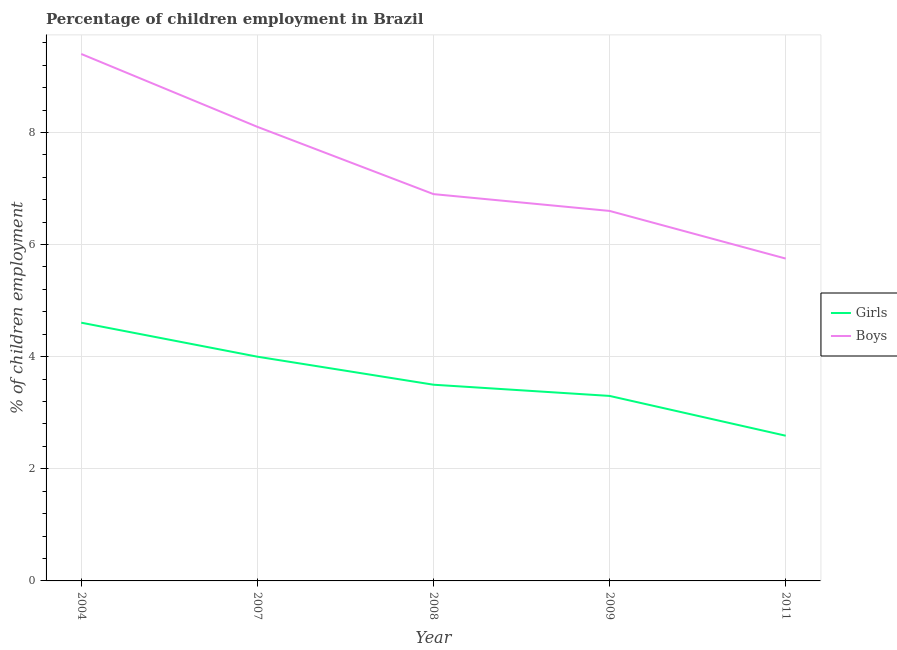How many different coloured lines are there?
Keep it short and to the point. 2. Does the line corresponding to percentage of employed girls intersect with the line corresponding to percentage of employed boys?
Offer a very short reply. No. Across all years, what is the maximum percentage of employed boys?
Your answer should be compact. 9.4. Across all years, what is the minimum percentage of employed girls?
Your answer should be very brief. 2.59. In which year was the percentage of employed boys maximum?
Your answer should be very brief. 2004. In which year was the percentage of employed boys minimum?
Your answer should be very brief. 2011. What is the total percentage of employed girls in the graph?
Give a very brief answer. 18. What is the difference between the percentage of employed boys in 2004 and that in 2008?
Give a very brief answer. 2.5. What is the difference between the percentage of employed girls in 2004 and the percentage of employed boys in 2007?
Provide a short and direct response. -3.49. What is the average percentage of employed girls per year?
Offer a terse response. 3.6. In the year 2007, what is the difference between the percentage of employed boys and percentage of employed girls?
Your response must be concise. 4.1. What is the ratio of the percentage of employed girls in 2008 to that in 2009?
Offer a very short reply. 1.06. What is the difference between the highest and the second highest percentage of employed girls?
Give a very brief answer. 0.61. What is the difference between the highest and the lowest percentage of employed girls?
Provide a succinct answer. 2.02. Is the sum of the percentage of employed boys in 2007 and 2009 greater than the maximum percentage of employed girls across all years?
Your answer should be compact. Yes. What is the difference between two consecutive major ticks on the Y-axis?
Provide a short and direct response. 2. Are the values on the major ticks of Y-axis written in scientific E-notation?
Offer a very short reply. No. Does the graph contain any zero values?
Ensure brevity in your answer.  No. Does the graph contain grids?
Offer a terse response. Yes. What is the title of the graph?
Offer a terse response. Percentage of children employment in Brazil. Does "Taxes on exports" appear as one of the legend labels in the graph?
Offer a terse response. No. What is the label or title of the Y-axis?
Offer a very short reply. % of children employment. What is the % of children employment of Girls in 2004?
Keep it short and to the point. 4.61. What is the % of children employment of Boys in 2004?
Your answer should be compact. 9.4. What is the % of children employment in Girls in 2007?
Your answer should be very brief. 4. What is the % of children employment in Girls in 2009?
Keep it short and to the point. 3.3. What is the % of children employment of Girls in 2011?
Provide a succinct answer. 2.59. What is the % of children employment in Boys in 2011?
Keep it short and to the point. 5.75. Across all years, what is the maximum % of children employment of Girls?
Offer a very short reply. 4.61. Across all years, what is the maximum % of children employment of Boys?
Offer a terse response. 9.4. Across all years, what is the minimum % of children employment of Girls?
Your response must be concise. 2.59. Across all years, what is the minimum % of children employment in Boys?
Provide a short and direct response. 5.75. What is the total % of children employment of Girls in the graph?
Ensure brevity in your answer.  18. What is the total % of children employment in Boys in the graph?
Your answer should be very brief. 36.75. What is the difference between the % of children employment of Girls in 2004 and that in 2007?
Give a very brief answer. 0.61. What is the difference between the % of children employment in Boys in 2004 and that in 2007?
Offer a very short reply. 1.3. What is the difference between the % of children employment of Girls in 2004 and that in 2008?
Your response must be concise. 1.11. What is the difference between the % of children employment of Boys in 2004 and that in 2008?
Give a very brief answer. 2.5. What is the difference between the % of children employment of Girls in 2004 and that in 2009?
Your response must be concise. 1.31. What is the difference between the % of children employment in Boys in 2004 and that in 2009?
Give a very brief answer. 2.8. What is the difference between the % of children employment in Girls in 2004 and that in 2011?
Your answer should be compact. 2.02. What is the difference between the % of children employment in Boys in 2004 and that in 2011?
Offer a terse response. 3.65. What is the difference between the % of children employment in Boys in 2007 and that in 2008?
Offer a very short reply. 1.2. What is the difference between the % of children employment of Girls in 2007 and that in 2011?
Offer a terse response. 1.41. What is the difference between the % of children employment in Boys in 2007 and that in 2011?
Your answer should be very brief. 2.35. What is the difference between the % of children employment in Girls in 2008 and that in 2011?
Provide a succinct answer. 0.91. What is the difference between the % of children employment of Boys in 2008 and that in 2011?
Make the answer very short. 1.15. What is the difference between the % of children employment in Girls in 2009 and that in 2011?
Ensure brevity in your answer.  0.71. What is the difference between the % of children employment of Girls in 2004 and the % of children employment of Boys in 2007?
Offer a very short reply. -3.49. What is the difference between the % of children employment of Girls in 2004 and the % of children employment of Boys in 2008?
Ensure brevity in your answer.  -2.29. What is the difference between the % of children employment in Girls in 2004 and the % of children employment in Boys in 2009?
Offer a terse response. -1.99. What is the difference between the % of children employment of Girls in 2004 and the % of children employment of Boys in 2011?
Your answer should be very brief. -1.14. What is the difference between the % of children employment in Girls in 2007 and the % of children employment in Boys in 2011?
Keep it short and to the point. -1.75. What is the difference between the % of children employment in Girls in 2008 and the % of children employment in Boys in 2011?
Provide a short and direct response. -2.25. What is the difference between the % of children employment of Girls in 2009 and the % of children employment of Boys in 2011?
Your answer should be very brief. -2.45. What is the average % of children employment of Girls per year?
Your answer should be very brief. 3.6. What is the average % of children employment of Boys per year?
Keep it short and to the point. 7.35. In the year 2004, what is the difference between the % of children employment in Girls and % of children employment in Boys?
Keep it short and to the point. -4.79. In the year 2011, what is the difference between the % of children employment in Girls and % of children employment in Boys?
Make the answer very short. -3.16. What is the ratio of the % of children employment in Girls in 2004 to that in 2007?
Provide a succinct answer. 1.15. What is the ratio of the % of children employment in Boys in 2004 to that in 2007?
Your answer should be very brief. 1.16. What is the ratio of the % of children employment in Girls in 2004 to that in 2008?
Ensure brevity in your answer.  1.32. What is the ratio of the % of children employment in Boys in 2004 to that in 2008?
Give a very brief answer. 1.36. What is the ratio of the % of children employment of Girls in 2004 to that in 2009?
Your answer should be very brief. 1.4. What is the ratio of the % of children employment of Boys in 2004 to that in 2009?
Provide a short and direct response. 1.42. What is the ratio of the % of children employment of Girls in 2004 to that in 2011?
Offer a terse response. 1.78. What is the ratio of the % of children employment in Boys in 2004 to that in 2011?
Provide a short and direct response. 1.63. What is the ratio of the % of children employment in Boys in 2007 to that in 2008?
Give a very brief answer. 1.17. What is the ratio of the % of children employment in Girls in 2007 to that in 2009?
Provide a short and direct response. 1.21. What is the ratio of the % of children employment of Boys in 2007 to that in 2009?
Keep it short and to the point. 1.23. What is the ratio of the % of children employment in Girls in 2007 to that in 2011?
Keep it short and to the point. 1.54. What is the ratio of the % of children employment in Boys in 2007 to that in 2011?
Ensure brevity in your answer.  1.41. What is the ratio of the % of children employment in Girls in 2008 to that in 2009?
Offer a terse response. 1.06. What is the ratio of the % of children employment of Boys in 2008 to that in 2009?
Make the answer very short. 1.05. What is the ratio of the % of children employment of Girls in 2008 to that in 2011?
Offer a very short reply. 1.35. What is the ratio of the % of children employment of Boys in 2008 to that in 2011?
Ensure brevity in your answer.  1.2. What is the ratio of the % of children employment in Girls in 2009 to that in 2011?
Your response must be concise. 1.27. What is the ratio of the % of children employment of Boys in 2009 to that in 2011?
Offer a very short reply. 1.15. What is the difference between the highest and the second highest % of children employment in Girls?
Offer a very short reply. 0.61. What is the difference between the highest and the lowest % of children employment in Girls?
Make the answer very short. 2.02. What is the difference between the highest and the lowest % of children employment in Boys?
Give a very brief answer. 3.65. 